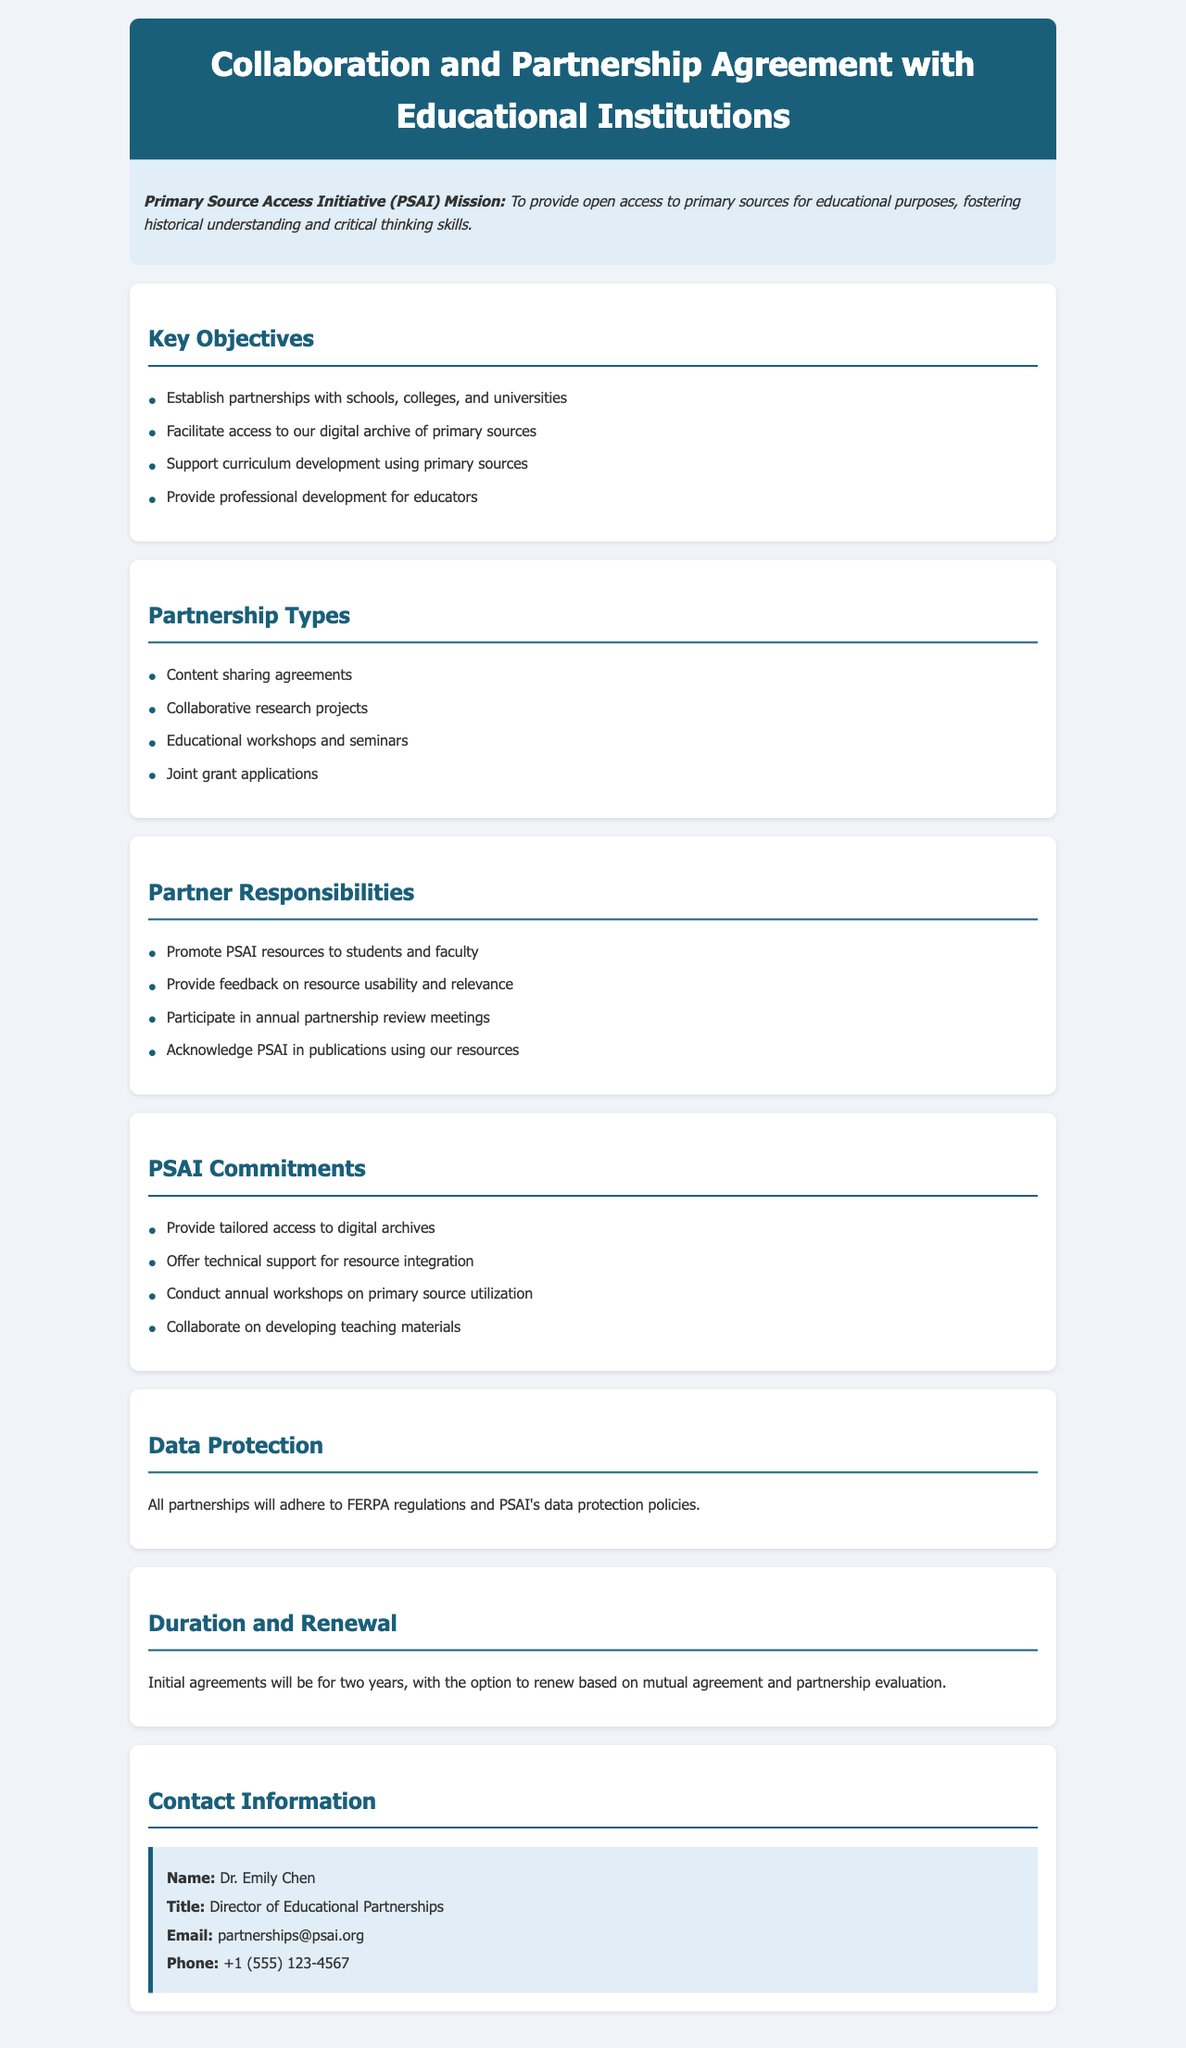What is PSAI's mission? The mission is to provide open access to primary sources for educational purposes, fostering historical understanding and critical thinking skills.
Answer: Providing open access to primary sources for educational purposes, fostering historical understanding and critical thinking skills How many key objectives are listed? The document specifies four key objectives under the "Key Objectives" section.
Answer: Four What type of partnership includes "joint grant applications"? This type of partnership is categorized under "Partnership Types".
Answer: Partnership Types Who is the director of educational partnerships? The name of the director is mentioned in the "Contact Information" section.
Answer: Dr. Emily Chen What is the duration of the initial agreements? The document states that initial agreements will last for two years.
Answer: Two years What does PSAI commit to providing regarding access? The commitments include tailored access to digital archives.
Answer: Tailored access to digital archives Which regulation does the document mention in the Data Protection section? The specific regulation referenced in the Data Protection section is FERPA.
Answer: FERPA How often are partnership review meetings held? The document indicates that these meetings are annual.
Answer: Annual What should partners do with PSAI resources in publications? Partners are required to acknowledge PSAI in publications that use their resources.
Answer: Acknowledge PSAI in publications 